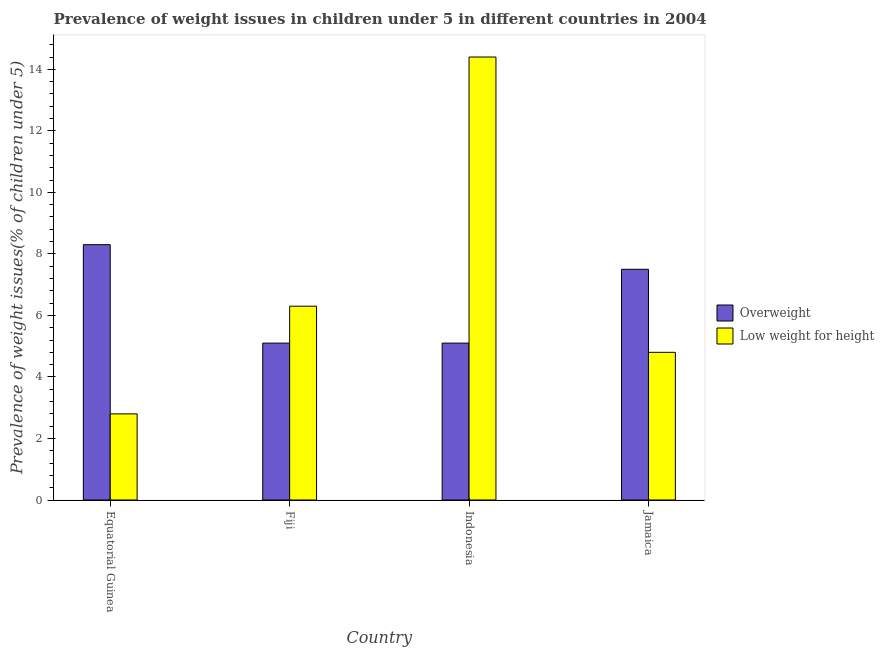Are the number of bars per tick equal to the number of legend labels?
Your answer should be compact. Yes. How many bars are there on the 4th tick from the right?
Your answer should be very brief. 2. What is the label of the 3rd group of bars from the left?
Offer a very short reply. Indonesia. In how many cases, is the number of bars for a given country not equal to the number of legend labels?
Your response must be concise. 0. What is the percentage of underweight children in Equatorial Guinea?
Your response must be concise. 2.8. Across all countries, what is the maximum percentage of underweight children?
Offer a very short reply. 14.4. Across all countries, what is the minimum percentage of overweight children?
Give a very brief answer. 5.1. In which country was the percentage of overweight children maximum?
Your response must be concise. Equatorial Guinea. In which country was the percentage of underweight children minimum?
Your answer should be very brief. Equatorial Guinea. What is the total percentage of underweight children in the graph?
Give a very brief answer. 28.3. What is the difference between the percentage of overweight children in Equatorial Guinea and that in Fiji?
Your response must be concise. 3.2. What is the difference between the percentage of overweight children in Equatorial Guinea and the percentage of underweight children in Jamaica?
Provide a succinct answer. 3.5. What is the average percentage of underweight children per country?
Your answer should be compact. 7.07. What is the difference between the percentage of underweight children and percentage of overweight children in Equatorial Guinea?
Your answer should be very brief. -5.5. In how many countries, is the percentage of underweight children greater than 7.2 %?
Your response must be concise. 1. What is the ratio of the percentage of overweight children in Fiji to that in Jamaica?
Make the answer very short. 0.68. Is the percentage of overweight children in Equatorial Guinea less than that in Jamaica?
Your answer should be compact. No. Is the difference between the percentage of underweight children in Equatorial Guinea and Jamaica greater than the difference between the percentage of overweight children in Equatorial Guinea and Jamaica?
Offer a terse response. No. What is the difference between the highest and the second highest percentage of underweight children?
Keep it short and to the point. 8.1. What is the difference between the highest and the lowest percentage of overweight children?
Keep it short and to the point. 3.2. Is the sum of the percentage of underweight children in Equatorial Guinea and Fiji greater than the maximum percentage of overweight children across all countries?
Make the answer very short. Yes. What does the 1st bar from the left in Jamaica represents?
Your answer should be very brief. Overweight. What does the 2nd bar from the right in Fiji represents?
Give a very brief answer. Overweight. How many bars are there?
Ensure brevity in your answer.  8. How many countries are there in the graph?
Offer a very short reply. 4. Where does the legend appear in the graph?
Your response must be concise. Center right. How are the legend labels stacked?
Ensure brevity in your answer.  Vertical. What is the title of the graph?
Provide a succinct answer. Prevalence of weight issues in children under 5 in different countries in 2004. What is the label or title of the X-axis?
Provide a short and direct response. Country. What is the label or title of the Y-axis?
Offer a very short reply. Prevalence of weight issues(% of children under 5). What is the Prevalence of weight issues(% of children under 5) in Overweight in Equatorial Guinea?
Give a very brief answer. 8.3. What is the Prevalence of weight issues(% of children under 5) of Low weight for height in Equatorial Guinea?
Your answer should be compact. 2.8. What is the Prevalence of weight issues(% of children under 5) in Overweight in Fiji?
Make the answer very short. 5.1. What is the Prevalence of weight issues(% of children under 5) in Low weight for height in Fiji?
Keep it short and to the point. 6.3. What is the Prevalence of weight issues(% of children under 5) of Overweight in Indonesia?
Give a very brief answer. 5.1. What is the Prevalence of weight issues(% of children under 5) of Low weight for height in Indonesia?
Provide a short and direct response. 14.4. What is the Prevalence of weight issues(% of children under 5) of Overweight in Jamaica?
Your answer should be compact. 7.5. What is the Prevalence of weight issues(% of children under 5) of Low weight for height in Jamaica?
Offer a very short reply. 4.8. Across all countries, what is the maximum Prevalence of weight issues(% of children under 5) of Overweight?
Your answer should be very brief. 8.3. Across all countries, what is the maximum Prevalence of weight issues(% of children under 5) of Low weight for height?
Offer a terse response. 14.4. Across all countries, what is the minimum Prevalence of weight issues(% of children under 5) of Overweight?
Give a very brief answer. 5.1. Across all countries, what is the minimum Prevalence of weight issues(% of children under 5) in Low weight for height?
Give a very brief answer. 2.8. What is the total Prevalence of weight issues(% of children under 5) in Overweight in the graph?
Provide a short and direct response. 26. What is the total Prevalence of weight issues(% of children under 5) in Low weight for height in the graph?
Offer a terse response. 28.3. What is the difference between the Prevalence of weight issues(% of children under 5) of Low weight for height in Equatorial Guinea and that in Fiji?
Keep it short and to the point. -3.5. What is the difference between the Prevalence of weight issues(% of children under 5) of Low weight for height in Equatorial Guinea and that in Indonesia?
Your answer should be very brief. -11.6. What is the difference between the Prevalence of weight issues(% of children under 5) in Overweight in Equatorial Guinea and that in Jamaica?
Ensure brevity in your answer.  0.8. What is the difference between the Prevalence of weight issues(% of children under 5) in Low weight for height in Equatorial Guinea and that in Jamaica?
Provide a short and direct response. -2. What is the difference between the Prevalence of weight issues(% of children under 5) of Low weight for height in Fiji and that in Indonesia?
Make the answer very short. -8.1. What is the difference between the Prevalence of weight issues(% of children under 5) of Overweight in Fiji and that in Jamaica?
Give a very brief answer. -2.4. What is the difference between the Prevalence of weight issues(% of children under 5) in Overweight in Indonesia and that in Jamaica?
Ensure brevity in your answer.  -2.4. What is the difference between the Prevalence of weight issues(% of children under 5) of Low weight for height in Indonesia and that in Jamaica?
Give a very brief answer. 9.6. What is the difference between the Prevalence of weight issues(% of children under 5) of Overweight in Equatorial Guinea and the Prevalence of weight issues(% of children under 5) of Low weight for height in Indonesia?
Offer a very short reply. -6.1. What is the difference between the Prevalence of weight issues(% of children under 5) of Overweight in Fiji and the Prevalence of weight issues(% of children under 5) of Low weight for height in Jamaica?
Offer a terse response. 0.3. What is the difference between the Prevalence of weight issues(% of children under 5) in Overweight in Indonesia and the Prevalence of weight issues(% of children under 5) in Low weight for height in Jamaica?
Provide a succinct answer. 0.3. What is the average Prevalence of weight issues(% of children under 5) of Overweight per country?
Your answer should be very brief. 6.5. What is the average Prevalence of weight issues(% of children under 5) of Low weight for height per country?
Your answer should be compact. 7.08. What is the difference between the Prevalence of weight issues(% of children under 5) of Overweight and Prevalence of weight issues(% of children under 5) of Low weight for height in Equatorial Guinea?
Your answer should be very brief. 5.5. What is the difference between the Prevalence of weight issues(% of children under 5) in Overweight and Prevalence of weight issues(% of children under 5) in Low weight for height in Indonesia?
Ensure brevity in your answer.  -9.3. What is the difference between the Prevalence of weight issues(% of children under 5) in Overweight and Prevalence of weight issues(% of children under 5) in Low weight for height in Jamaica?
Provide a succinct answer. 2.7. What is the ratio of the Prevalence of weight issues(% of children under 5) of Overweight in Equatorial Guinea to that in Fiji?
Provide a succinct answer. 1.63. What is the ratio of the Prevalence of weight issues(% of children under 5) of Low weight for height in Equatorial Guinea to that in Fiji?
Ensure brevity in your answer.  0.44. What is the ratio of the Prevalence of weight issues(% of children under 5) of Overweight in Equatorial Guinea to that in Indonesia?
Your response must be concise. 1.63. What is the ratio of the Prevalence of weight issues(% of children under 5) in Low weight for height in Equatorial Guinea to that in Indonesia?
Offer a very short reply. 0.19. What is the ratio of the Prevalence of weight issues(% of children under 5) in Overweight in Equatorial Guinea to that in Jamaica?
Give a very brief answer. 1.11. What is the ratio of the Prevalence of weight issues(% of children under 5) of Low weight for height in Equatorial Guinea to that in Jamaica?
Ensure brevity in your answer.  0.58. What is the ratio of the Prevalence of weight issues(% of children under 5) of Overweight in Fiji to that in Indonesia?
Provide a succinct answer. 1. What is the ratio of the Prevalence of weight issues(% of children under 5) of Low weight for height in Fiji to that in Indonesia?
Offer a very short reply. 0.44. What is the ratio of the Prevalence of weight issues(% of children under 5) in Overweight in Fiji to that in Jamaica?
Provide a short and direct response. 0.68. What is the ratio of the Prevalence of weight issues(% of children under 5) of Low weight for height in Fiji to that in Jamaica?
Make the answer very short. 1.31. What is the ratio of the Prevalence of weight issues(% of children under 5) in Overweight in Indonesia to that in Jamaica?
Provide a short and direct response. 0.68. What is the difference between the highest and the second highest Prevalence of weight issues(% of children under 5) in Overweight?
Provide a short and direct response. 0.8. What is the difference between the highest and the second highest Prevalence of weight issues(% of children under 5) of Low weight for height?
Keep it short and to the point. 8.1. What is the difference between the highest and the lowest Prevalence of weight issues(% of children under 5) in Overweight?
Give a very brief answer. 3.2. What is the difference between the highest and the lowest Prevalence of weight issues(% of children under 5) of Low weight for height?
Give a very brief answer. 11.6. 